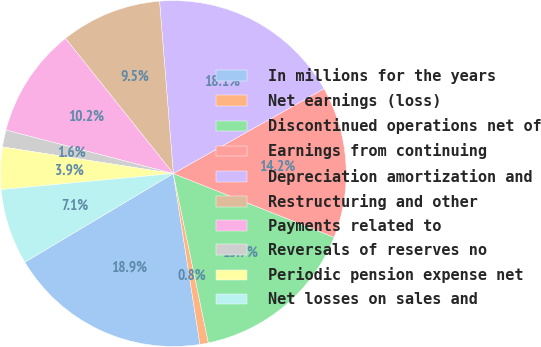Convert chart. <chart><loc_0><loc_0><loc_500><loc_500><pie_chart><fcel>In millions for the years<fcel>Net earnings (loss)<fcel>Discontinued operations net of<fcel>Earnings from continuing<fcel>Depreciation amortization and<fcel>Restructuring and other<fcel>Payments related to<fcel>Reversals of reserves no<fcel>Periodic pension expense net<fcel>Net losses on sales and<nl><fcel>18.89%<fcel>0.79%<fcel>15.74%<fcel>14.17%<fcel>18.1%<fcel>9.45%<fcel>10.24%<fcel>1.58%<fcel>3.94%<fcel>7.09%<nl></chart> 